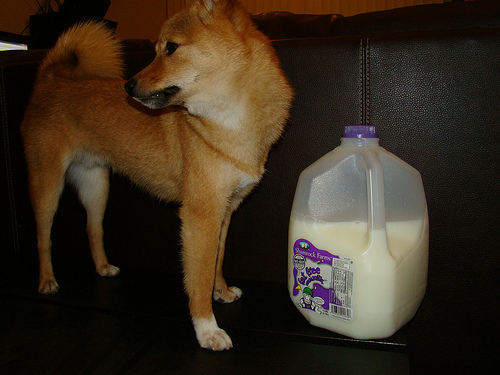<image>
Is the dog behind the milk? No. The dog is not behind the milk. From this viewpoint, the dog appears to be positioned elsewhere in the scene. Where is the milk in relation to the dog? Is it in front of the dog? Yes. The milk is positioned in front of the dog, appearing closer to the camera viewpoint. 